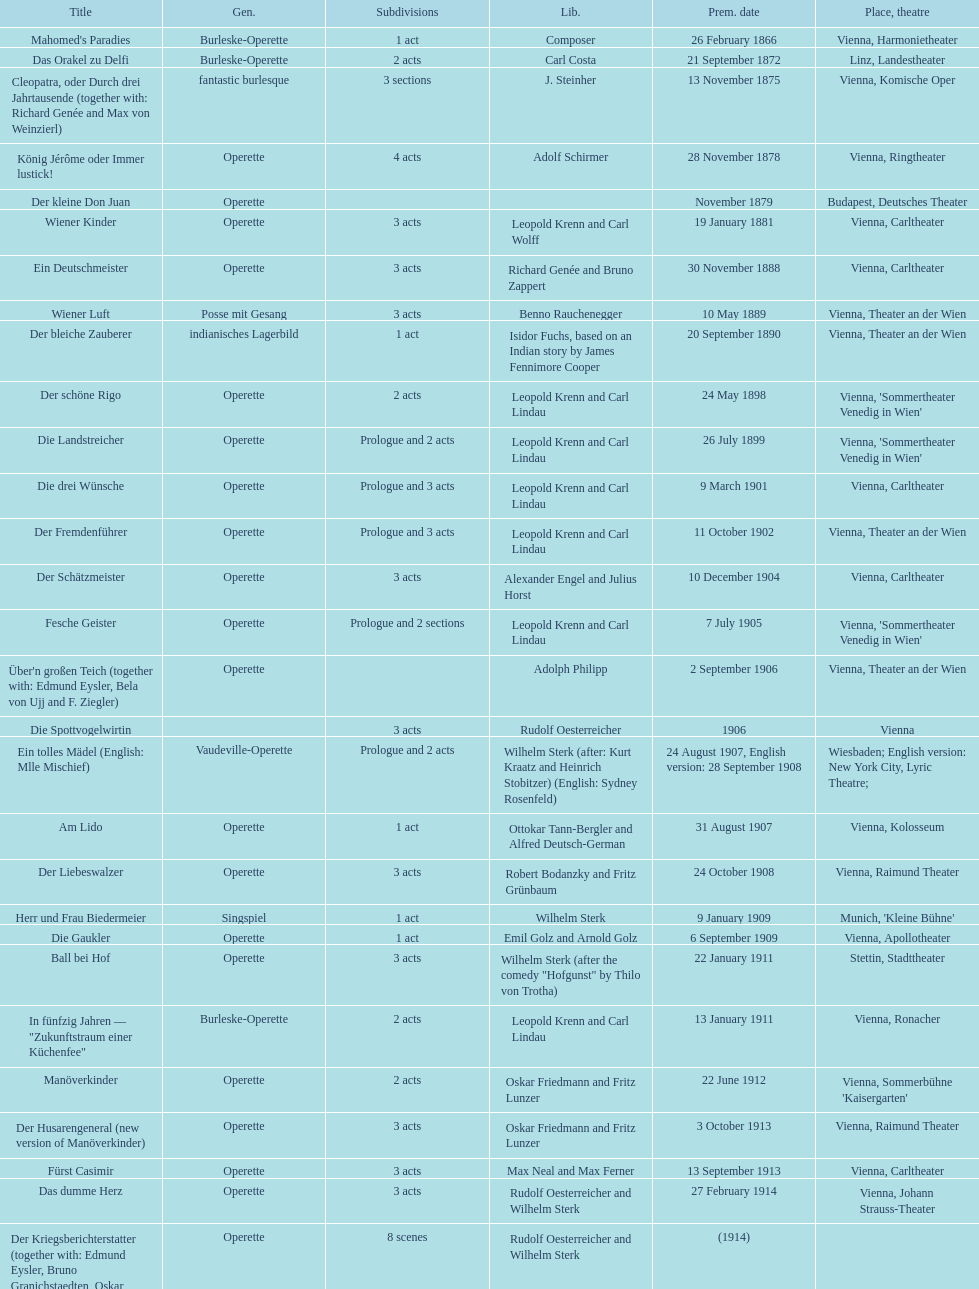Does der liebeswalzer or manöverkinder contain more acts? Der Liebeswalzer. 